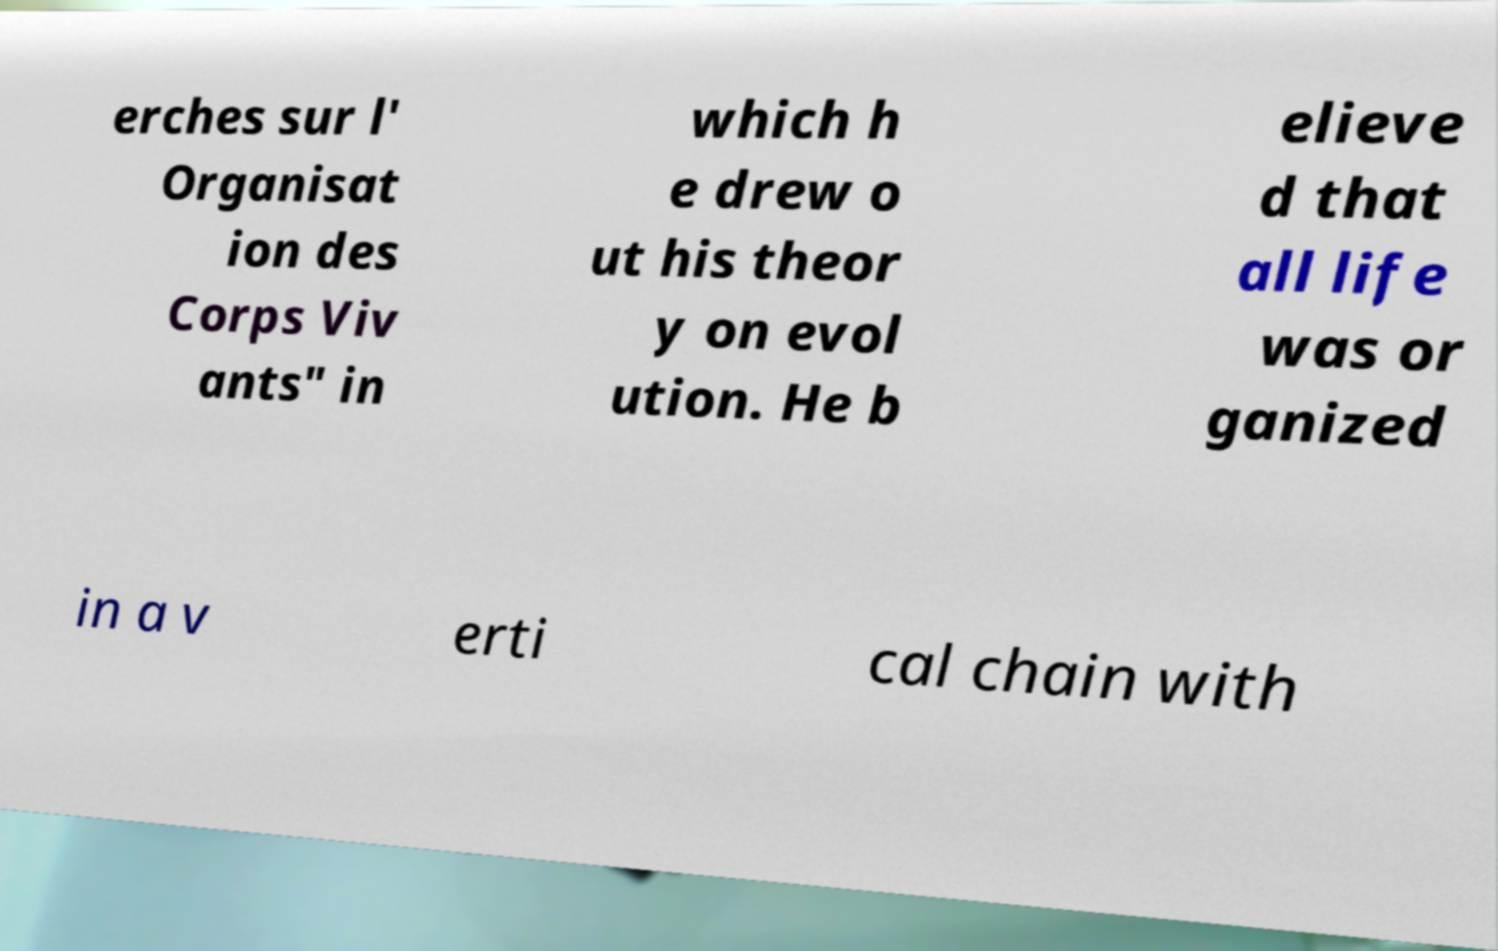There's text embedded in this image that I need extracted. Can you transcribe it verbatim? erches sur l' Organisat ion des Corps Viv ants" in which h e drew o ut his theor y on evol ution. He b elieve d that all life was or ganized in a v erti cal chain with 